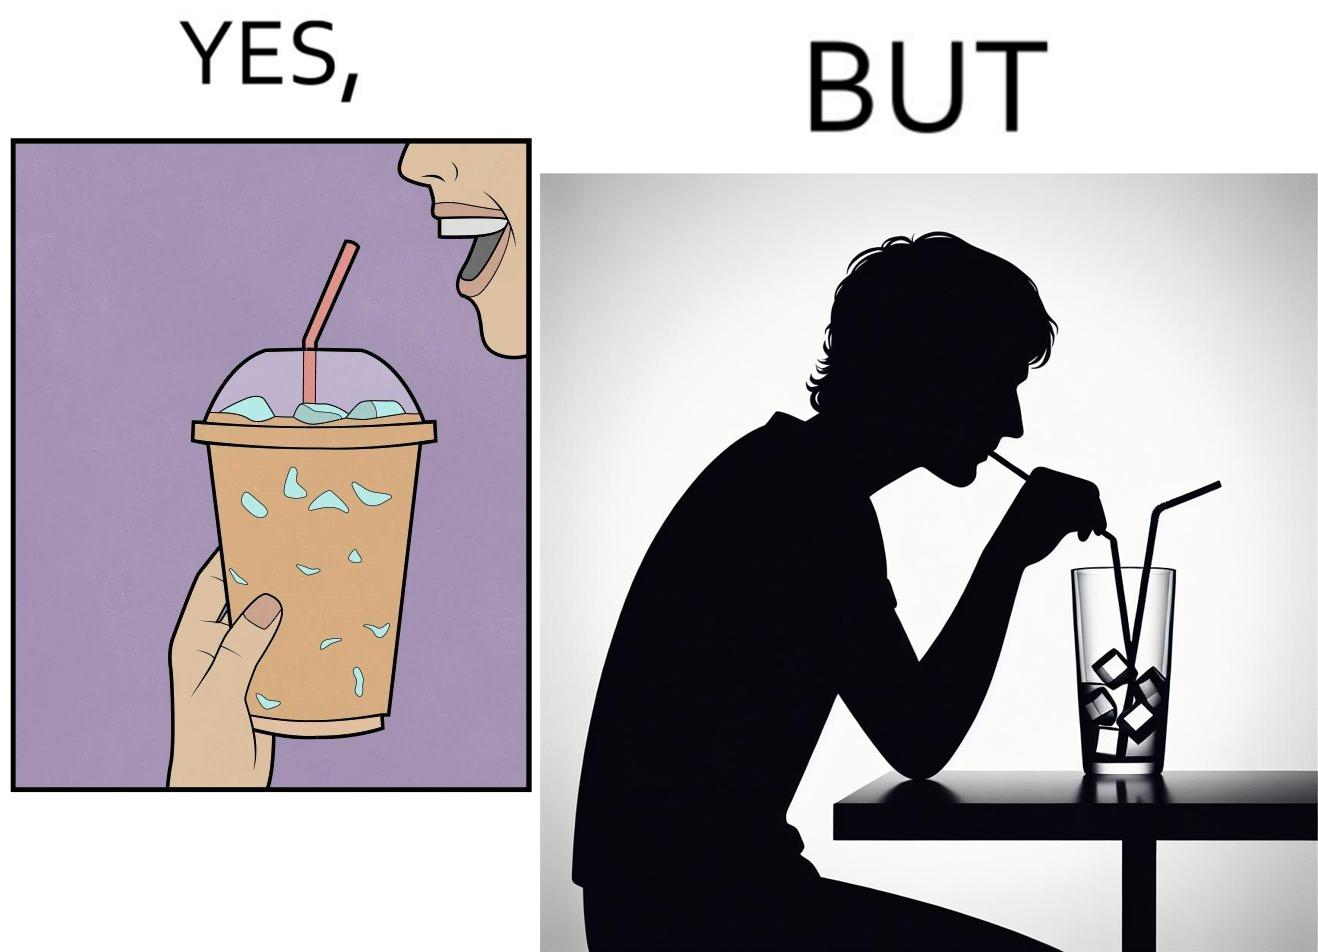Would you classify this image as satirical? Yes, this image is satirical. 